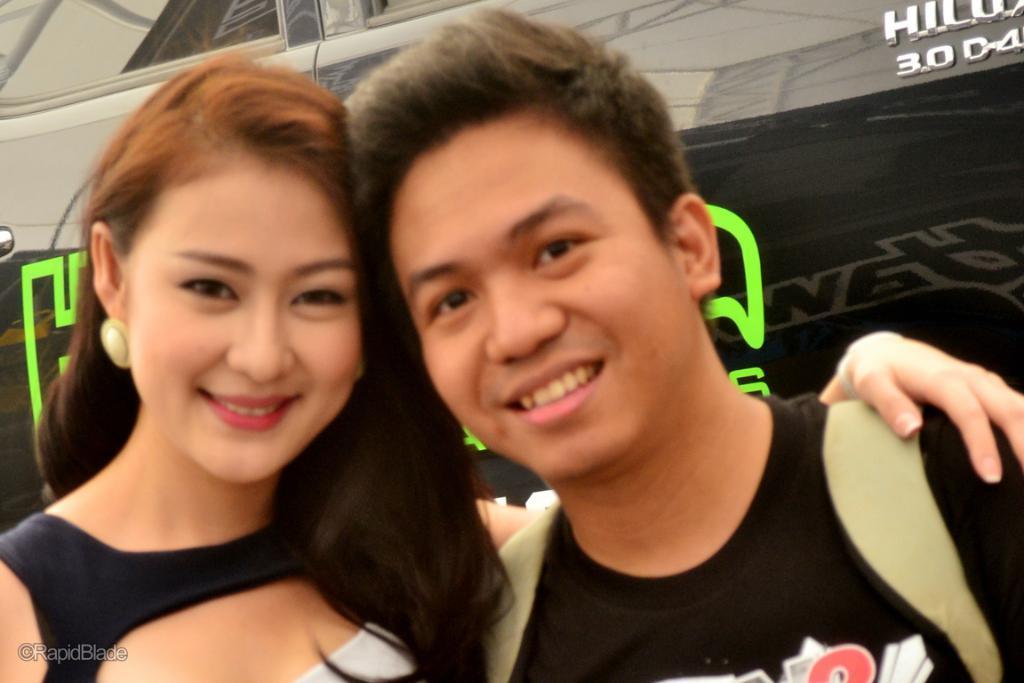In one or two sentences, can you explain what this image depicts? In this image we can see few persons. There is a vehicle in the image. There are some reflections on the vehicle. There is some text on the vehicle. 